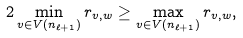Convert formula to latex. <formula><loc_0><loc_0><loc_500><loc_500>2 \min _ { v \in V ( n _ { \ell + 1 } ) } r _ { v , w } \geq \max _ { v \in V ( n _ { \ell + 1 } ) } r _ { v , w } ,</formula> 